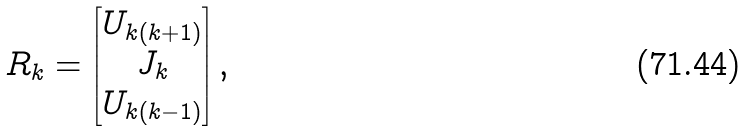Convert formula to latex. <formula><loc_0><loc_0><loc_500><loc_500>R _ { k } = \left [ \begin{matrix} U _ { k ( k + 1 ) } \\ J _ { k } \\ U _ { k ( k - 1 ) } \end{matrix} \right ] ,</formula> 